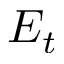<formula> <loc_0><loc_0><loc_500><loc_500>E _ { t }</formula> 